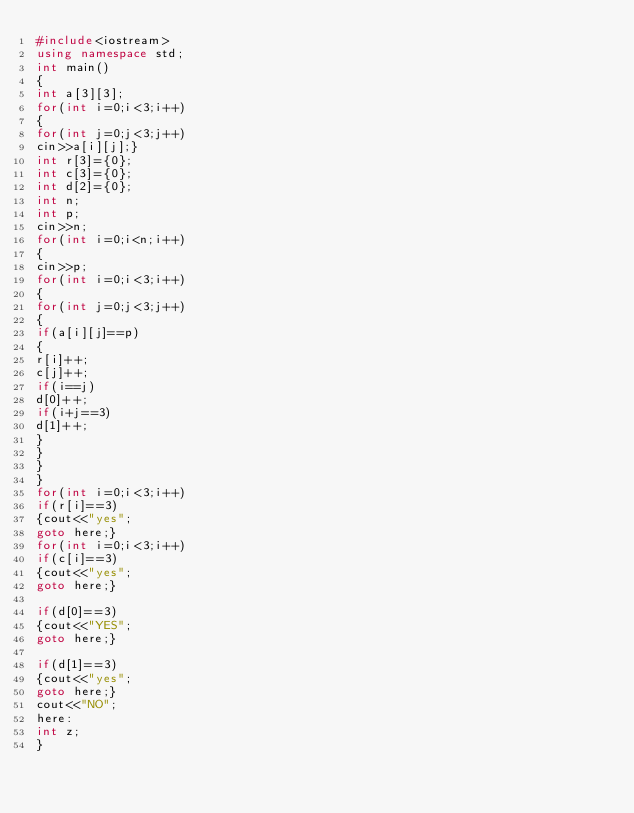<code> <loc_0><loc_0><loc_500><loc_500><_C++_>#include<iostream>
using namespace std;
int main()
{
int a[3][3];
for(int i=0;i<3;i++)
{
for(int j=0;j<3;j++)
cin>>a[i][j];}
int r[3]={0};
int c[3]={0};
int d[2]={0};
int n;
int p;
cin>>n;
for(int i=0;i<n;i++)
{
cin>>p;
for(int i=0;i<3;i++)
{
for(int j=0;j<3;j++)
{
if(a[i][j]==p)
{
r[i]++;
c[j]++;
if(i==j)
d[0]++;
if(i+j==3)
d[1]++;
}
}
}
}
for(int i=0;i<3;i++)
if(r[i]==3)
{cout<<"yes";
goto here;}
for(int i=0;i<3;i++)
if(c[i]==3)
{cout<<"yes";
goto here;}
 
if(d[0]==3)
{cout<<"YES";
goto here;}
 
if(d[1]==3)
{cout<<"yes";
goto here;}
cout<<"NO";
here:
int z;
}</code> 